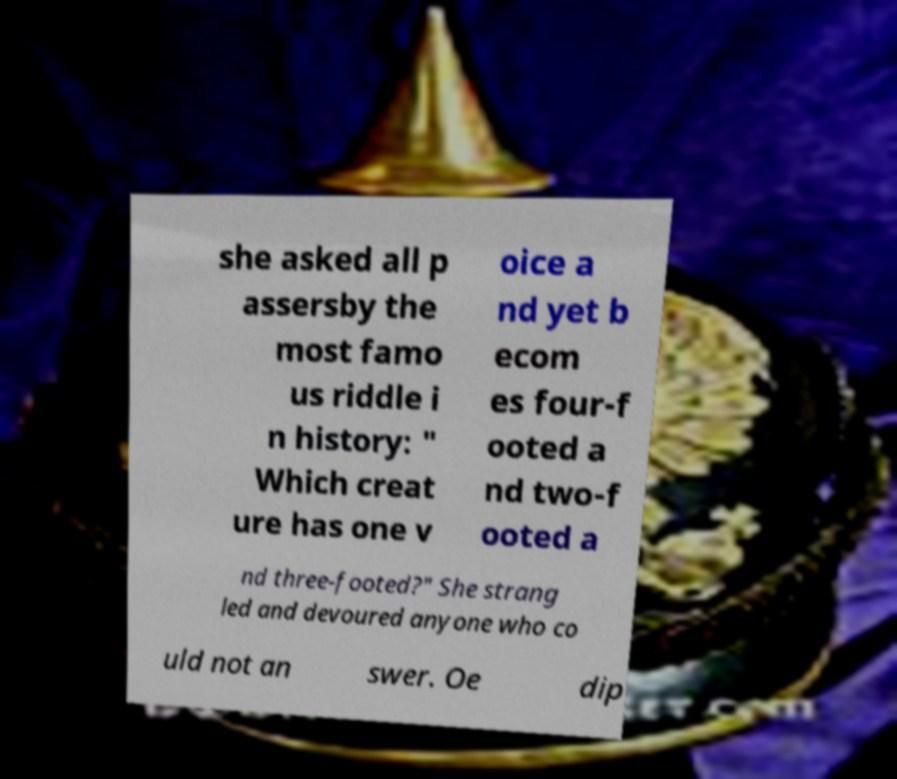Could you extract and type out the text from this image? she asked all p assersby the most famo us riddle i n history: " Which creat ure has one v oice a nd yet b ecom es four-f ooted a nd two-f ooted a nd three-footed?" She strang led and devoured anyone who co uld not an swer. Oe dip 